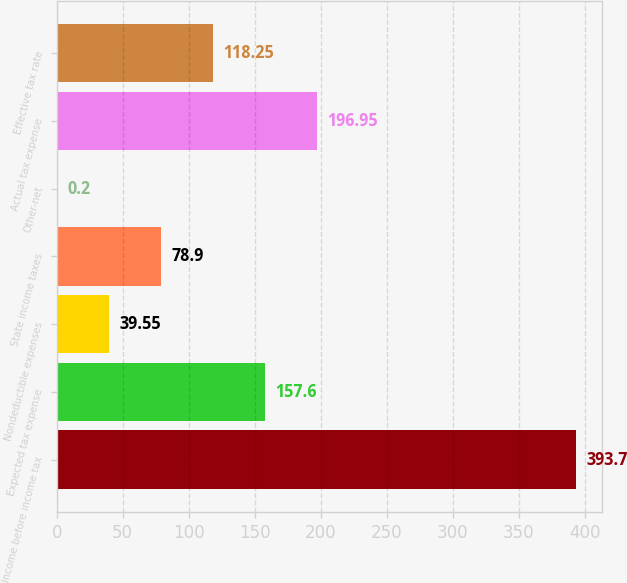<chart> <loc_0><loc_0><loc_500><loc_500><bar_chart><fcel>Income before income tax<fcel>Expected tax expense<fcel>Nondeductible expenses<fcel>State income taxes<fcel>Other-net<fcel>Actual tax expense<fcel>Effective tax rate<nl><fcel>393.7<fcel>157.6<fcel>39.55<fcel>78.9<fcel>0.2<fcel>196.95<fcel>118.25<nl></chart> 